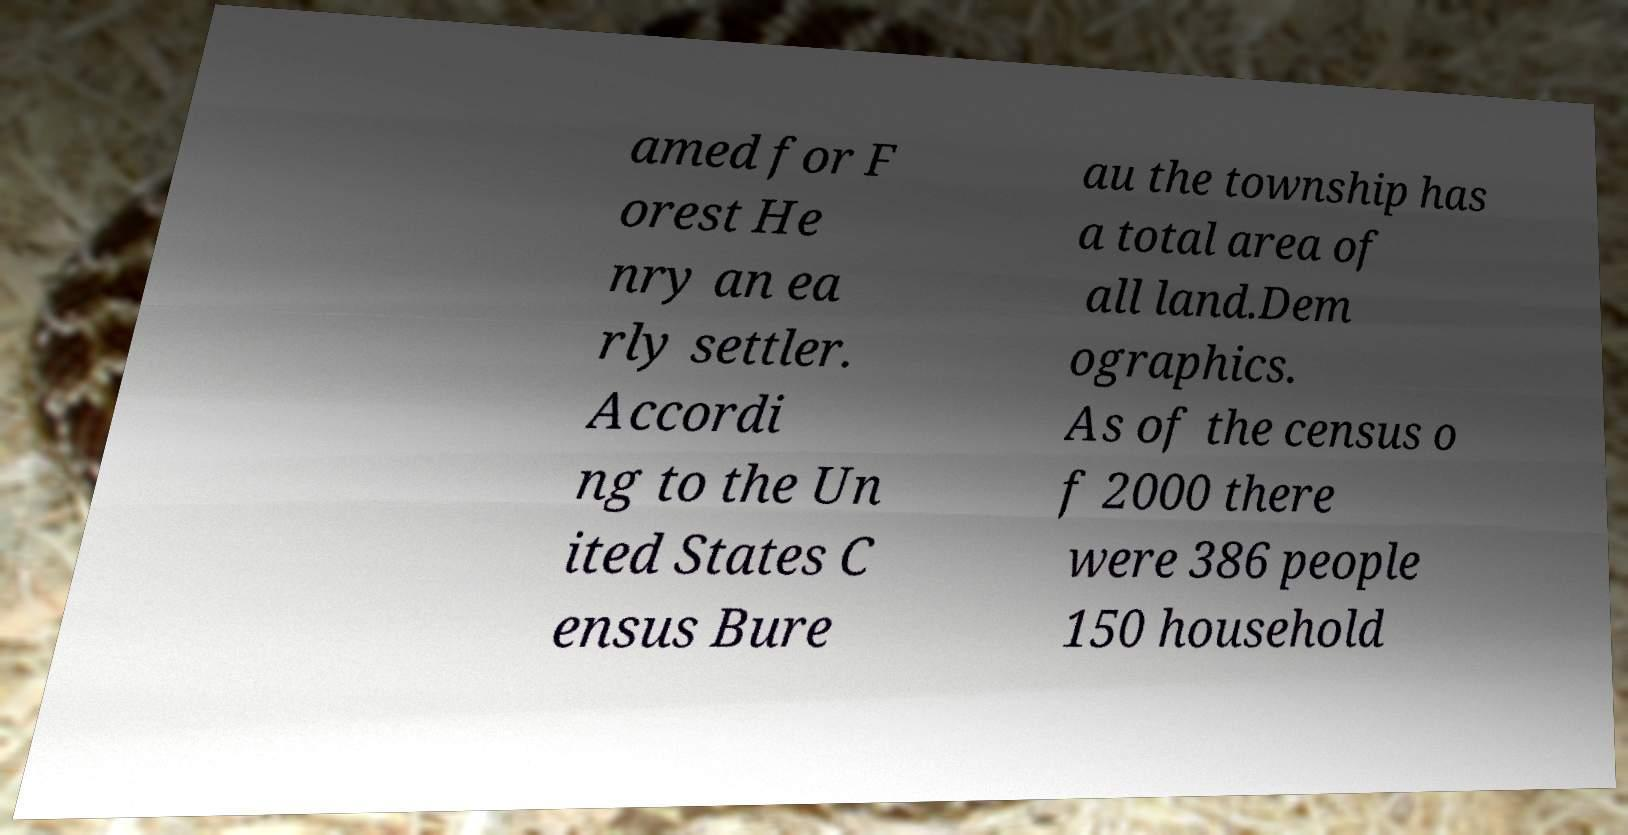There's text embedded in this image that I need extracted. Can you transcribe it verbatim? amed for F orest He nry an ea rly settler. Accordi ng to the Un ited States C ensus Bure au the township has a total area of all land.Dem ographics. As of the census o f 2000 there were 386 people 150 household 